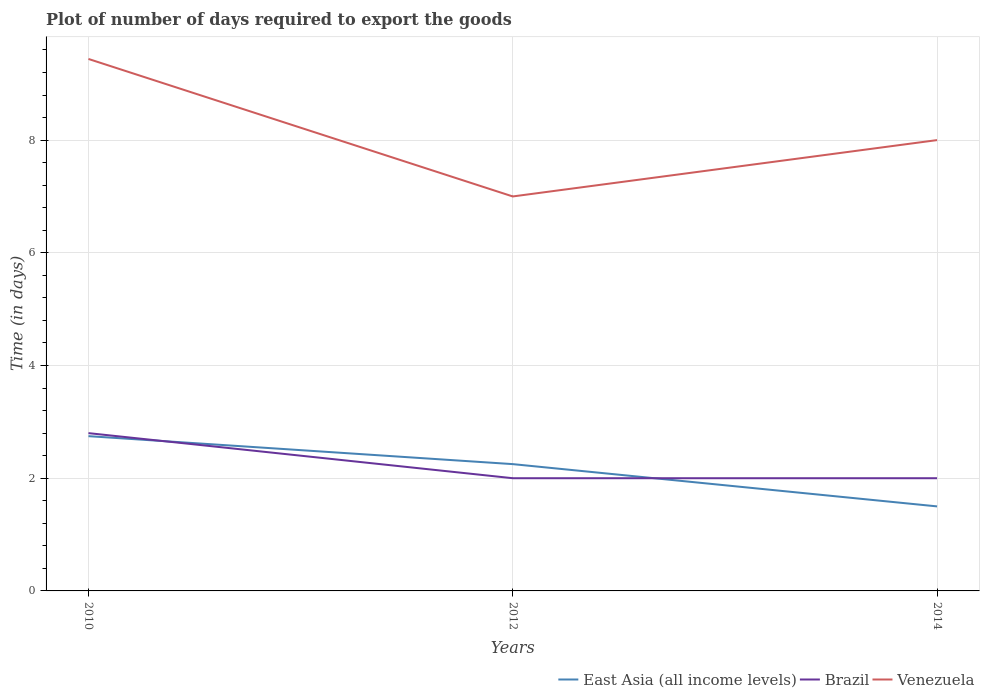Is the number of lines equal to the number of legend labels?
Make the answer very short. Yes. In which year was the time required to export goods in East Asia (all income levels) maximum?
Your answer should be very brief. 2014. What is the total time required to export goods in Venezuela in the graph?
Your answer should be very brief. 2.44. What is the difference between the highest and the second highest time required to export goods in Venezuela?
Provide a short and direct response. 2.44. Is the time required to export goods in Venezuela strictly greater than the time required to export goods in East Asia (all income levels) over the years?
Provide a short and direct response. No. How many lines are there?
Provide a succinct answer. 3. How many years are there in the graph?
Offer a very short reply. 3. Are the values on the major ticks of Y-axis written in scientific E-notation?
Your answer should be very brief. No. Does the graph contain grids?
Provide a succinct answer. Yes. How many legend labels are there?
Offer a very short reply. 3. What is the title of the graph?
Your answer should be very brief. Plot of number of days required to export the goods. Does "Kazakhstan" appear as one of the legend labels in the graph?
Your answer should be compact. No. What is the label or title of the X-axis?
Make the answer very short. Years. What is the label or title of the Y-axis?
Offer a very short reply. Time (in days). What is the Time (in days) of East Asia (all income levels) in 2010?
Offer a terse response. 2.75. What is the Time (in days) in Venezuela in 2010?
Give a very brief answer. 9.44. What is the Time (in days) of East Asia (all income levels) in 2012?
Offer a terse response. 2.25. What is the Time (in days) in Brazil in 2012?
Provide a succinct answer. 2. What is the Time (in days) in Venezuela in 2012?
Your answer should be very brief. 7. What is the Time (in days) of Brazil in 2014?
Ensure brevity in your answer.  2. Across all years, what is the maximum Time (in days) in East Asia (all income levels)?
Offer a terse response. 2.75. Across all years, what is the maximum Time (in days) of Venezuela?
Make the answer very short. 9.44. Across all years, what is the minimum Time (in days) of Brazil?
Give a very brief answer. 2. Across all years, what is the minimum Time (in days) in Venezuela?
Your answer should be very brief. 7. What is the total Time (in days) in East Asia (all income levels) in the graph?
Your answer should be very brief. 6.5. What is the total Time (in days) in Venezuela in the graph?
Your answer should be very brief. 24.44. What is the difference between the Time (in days) in East Asia (all income levels) in 2010 and that in 2012?
Keep it short and to the point. 0.5. What is the difference between the Time (in days) of Venezuela in 2010 and that in 2012?
Provide a succinct answer. 2.44. What is the difference between the Time (in days) of East Asia (all income levels) in 2010 and that in 2014?
Your response must be concise. 1.25. What is the difference between the Time (in days) of Brazil in 2010 and that in 2014?
Your response must be concise. 0.8. What is the difference between the Time (in days) of Venezuela in 2010 and that in 2014?
Ensure brevity in your answer.  1.44. What is the difference between the Time (in days) in East Asia (all income levels) in 2012 and that in 2014?
Give a very brief answer. 0.75. What is the difference between the Time (in days) of Venezuela in 2012 and that in 2014?
Your response must be concise. -1. What is the difference between the Time (in days) of East Asia (all income levels) in 2010 and the Time (in days) of Brazil in 2012?
Your response must be concise. 0.75. What is the difference between the Time (in days) of East Asia (all income levels) in 2010 and the Time (in days) of Venezuela in 2012?
Give a very brief answer. -4.25. What is the difference between the Time (in days) of East Asia (all income levels) in 2010 and the Time (in days) of Brazil in 2014?
Keep it short and to the point. 0.75. What is the difference between the Time (in days) of East Asia (all income levels) in 2010 and the Time (in days) of Venezuela in 2014?
Provide a short and direct response. -5.25. What is the difference between the Time (in days) of Brazil in 2010 and the Time (in days) of Venezuela in 2014?
Offer a very short reply. -5.2. What is the difference between the Time (in days) in East Asia (all income levels) in 2012 and the Time (in days) in Brazil in 2014?
Ensure brevity in your answer.  0.25. What is the difference between the Time (in days) of East Asia (all income levels) in 2012 and the Time (in days) of Venezuela in 2014?
Offer a terse response. -5.75. What is the average Time (in days) in East Asia (all income levels) per year?
Make the answer very short. 2.17. What is the average Time (in days) in Brazil per year?
Give a very brief answer. 2.27. What is the average Time (in days) in Venezuela per year?
Your response must be concise. 8.15. In the year 2010, what is the difference between the Time (in days) of East Asia (all income levels) and Time (in days) of Brazil?
Provide a succinct answer. -0.05. In the year 2010, what is the difference between the Time (in days) in East Asia (all income levels) and Time (in days) in Venezuela?
Make the answer very short. -6.69. In the year 2010, what is the difference between the Time (in days) in Brazil and Time (in days) in Venezuela?
Provide a short and direct response. -6.64. In the year 2012, what is the difference between the Time (in days) of East Asia (all income levels) and Time (in days) of Venezuela?
Make the answer very short. -4.75. In the year 2014, what is the difference between the Time (in days) of Brazil and Time (in days) of Venezuela?
Ensure brevity in your answer.  -6. What is the ratio of the Time (in days) of East Asia (all income levels) in 2010 to that in 2012?
Make the answer very short. 1.22. What is the ratio of the Time (in days) in Brazil in 2010 to that in 2012?
Offer a terse response. 1.4. What is the ratio of the Time (in days) of Venezuela in 2010 to that in 2012?
Give a very brief answer. 1.35. What is the ratio of the Time (in days) of East Asia (all income levels) in 2010 to that in 2014?
Your response must be concise. 1.83. What is the ratio of the Time (in days) of Brazil in 2010 to that in 2014?
Your answer should be very brief. 1.4. What is the ratio of the Time (in days) of Venezuela in 2010 to that in 2014?
Provide a short and direct response. 1.18. What is the ratio of the Time (in days) in East Asia (all income levels) in 2012 to that in 2014?
Offer a very short reply. 1.5. What is the ratio of the Time (in days) in Venezuela in 2012 to that in 2014?
Provide a short and direct response. 0.88. What is the difference between the highest and the second highest Time (in days) in East Asia (all income levels)?
Offer a terse response. 0.5. What is the difference between the highest and the second highest Time (in days) in Brazil?
Your answer should be compact. 0.8. What is the difference between the highest and the second highest Time (in days) in Venezuela?
Offer a very short reply. 1.44. What is the difference between the highest and the lowest Time (in days) of East Asia (all income levels)?
Keep it short and to the point. 1.25. What is the difference between the highest and the lowest Time (in days) of Brazil?
Offer a very short reply. 0.8. What is the difference between the highest and the lowest Time (in days) in Venezuela?
Your answer should be compact. 2.44. 